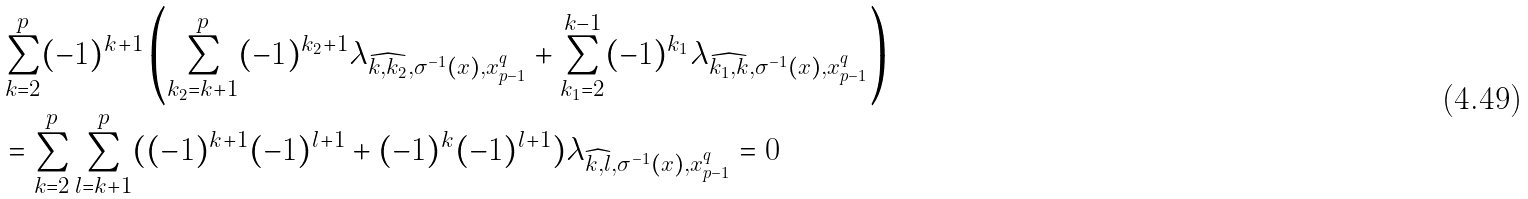<formula> <loc_0><loc_0><loc_500><loc_500>& \sum _ { k = 2 } ^ { p } ( - 1 ) ^ { k + 1 } \left ( \sum _ { k _ { 2 } = k + 1 } ^ { p } ( - 1 ) ^ { k _ { 2 } + 1 } \lambda _ { \widehat { k , k _ { 2 } } , \sigma ^ { - 1 } ( x ) , x _ { p - 1 } ^ { q } } + \sum _ { k _ { 1 } = 2 } ^ { k - 1 } ( - 1 ) ^ { k _ { 1 } } \lambda _ { \widehat { k _ { 1 } , k } , \sigma ^ { - 1 } ( x ) , x _ { p - 1 } ^ { q } } \right ) \\ & = \sum _ { k = 2 } ^ { p } \sum _ { l = k + 1 } ^ { p } ( ( - 1 ) ^ { k + 1 } ( - 1 ) ^ { l + 1 } + ( - 1 ) ^ { k } ( - 1 ) ^ { l + 1 } ) \lambda _ { \widehat { k , l } , \sigma ^ { - 1 } ( x ) , x _ { p - 1 } ^ { q } } = 0 \,</formula> 